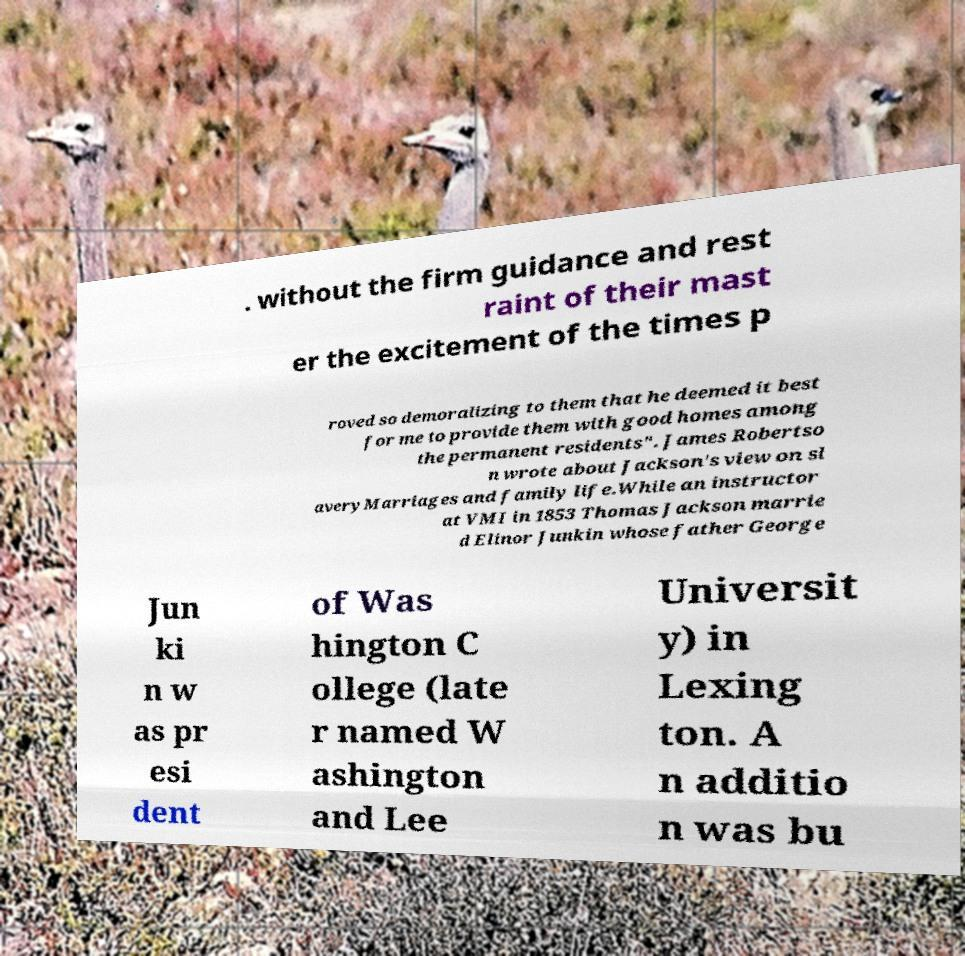Could you assist in decoding the text presented in this image and type it out clearly? . without the firm guidance and rest raint of their mast er the excitement of the times p roved so demoralizing to them that he deemed it best for me to provide them with good homes among the permanent residents". James Robertso n wrote about Jackson's view on sl averyMarriages and family life.While an instructor at VMI in 1853 Thomas Jackson marrie d Elinor Junkin whose father George Jun ki n w as pr esi dent of Was hington C ollege (late r named W ashington and Lee Universit y) in Lexing ton. A n additio n was bu 